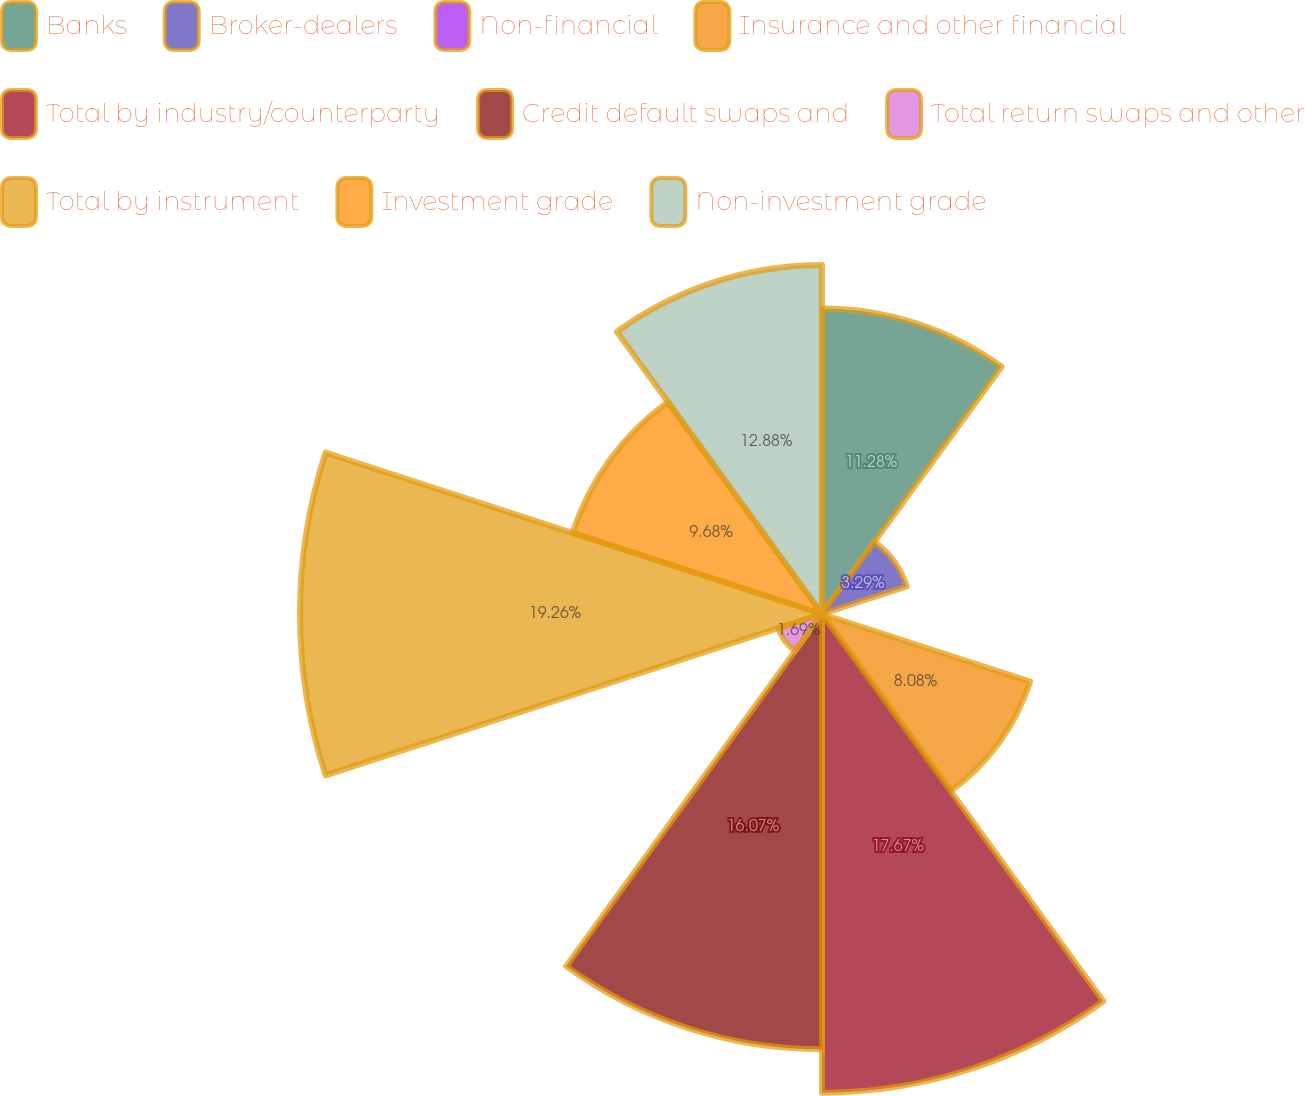Convert chart. <chart><loc_0><loc_0><loc_500><loc_500><pie_chart><fcel>Banks<fcel>Broker-dealers<fcel>Non-financial<fcel>Insurance and other financial<fcel>Total by industry/counterparty<fcel>Credit default swaps and<fcel>Total return swaps and other<fcel>Total by instrument<fcel>Investment grade<fcel>Non-investment grade<nl><fcel>11.28%<fcel>3.29%<fcel>0.1%<fcel>8.08%<fcel>17.67%<fcel>16.07%<fcel>1.69%<fcel>19.27%<fcel>9.68%<fcel>12.88%<nl></chart> 